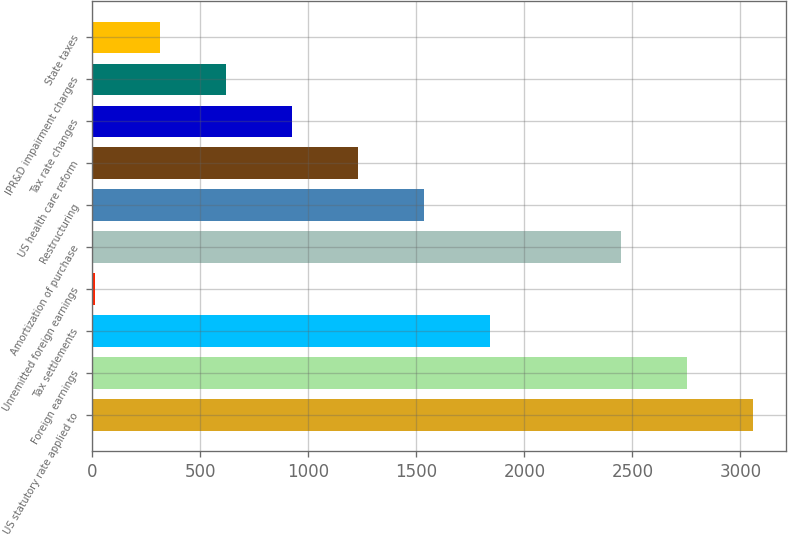<chart> <loc_0><loc_0><loc_500><loc_500><bar_chart><fcel>US statutory rate applied to<fcel>Foreign earnings<fcel>Tax settlements<fcel>Unremitted foreign earnings<fcel>Amortization of purchase<fcel>Restructuring<fcel>US health care reform<fcel>Tax rate changes<fcel>IPR&D impairment charges<fcel>State taxes<nl><fcel>3059<fcel>2754.2<fcel>1839.8<fcel>11<fcel>2449.4<fcel>1535<fcel>1230.2<fcel>925.4<fcel>620.6<fcel>315.8<nl></chart> 